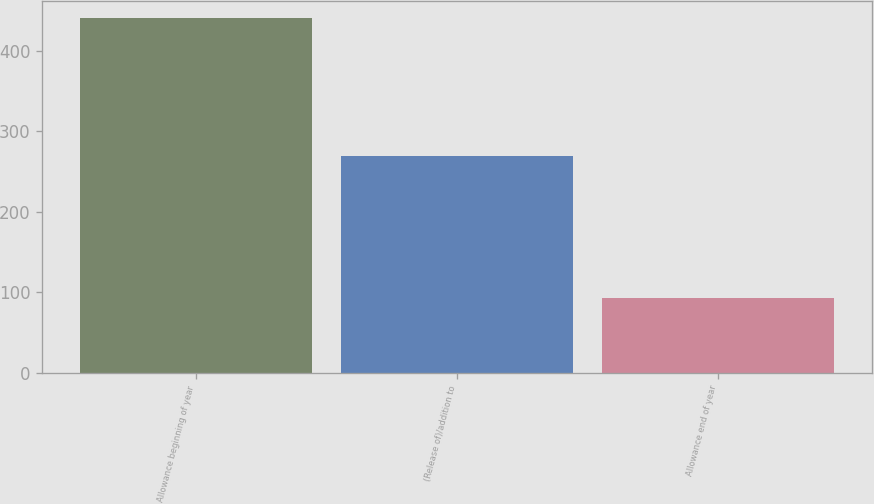Convert chart. <chart><loc_0><loc_0><loc_500><loc_500><bar_chart><fcel>Allowance beginning of year<fcel>(Release of)/addition to<fcel>Allowance end of year<nl><fcel>440<fcel>269<fcel>93<nl></chart> 